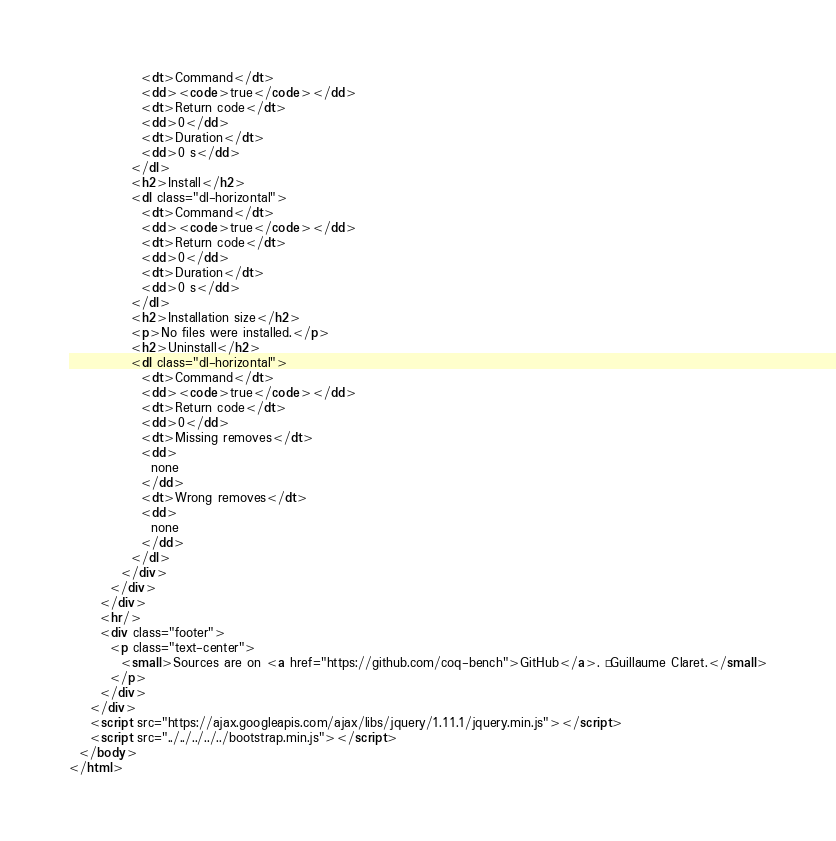<code> <loc_0><loc_0><loc_500><loc_500><_HTML_>              <dt>Command</dt>
              <dd><code>true</code></dd>
              <dt>Return code</dt>
              <dd>0</dd>
              <dt>Duration</dt>
              <dd>0 s</dd>
            </dl>
            <h2>Install</h2>
            <dl class="dl-horizontal">
              <dt>Command</dt>
              <dd><code>true</code></dd>
              <dt>Return code</dt>
              <dd>0</dd>
              <dt>Duration</dt>
              <dd>0 s</dd>
            </dl>
            <h2>Installation size</h2>
            <p>No files were installed.</p>
            <h2>Uninstall</h2>
            <dl class="dl-horizontal">
              <dt>Command</dt>
              <dd><code>true</code></dd>
              <dt>Return code</dt>
              <dd>0</dd>
              <dt>Missing removes</dt>
              <dd>
                none
              </dd>
              <dt>Wrong removes</dt>
              <dd>
                none
              </dd>
            </dl>
          </div>
        </div>
      </div>
      <hr/>
      <div class="footer">
        <p class="text-center">
          <small>Sources are on <a href="https://github.com/coq-bench">GitHub</a>. © Guillaume Claret.</small>
        </p>
      </div>
    </div>
    <script src="https://ajax.googleapis.com/ajax/libs/jquery/1.11.1/jquery.min.js"></script>
    <script src="../../../../../bootstrap.min.js"></script>
  </body>
</html>
</code> 